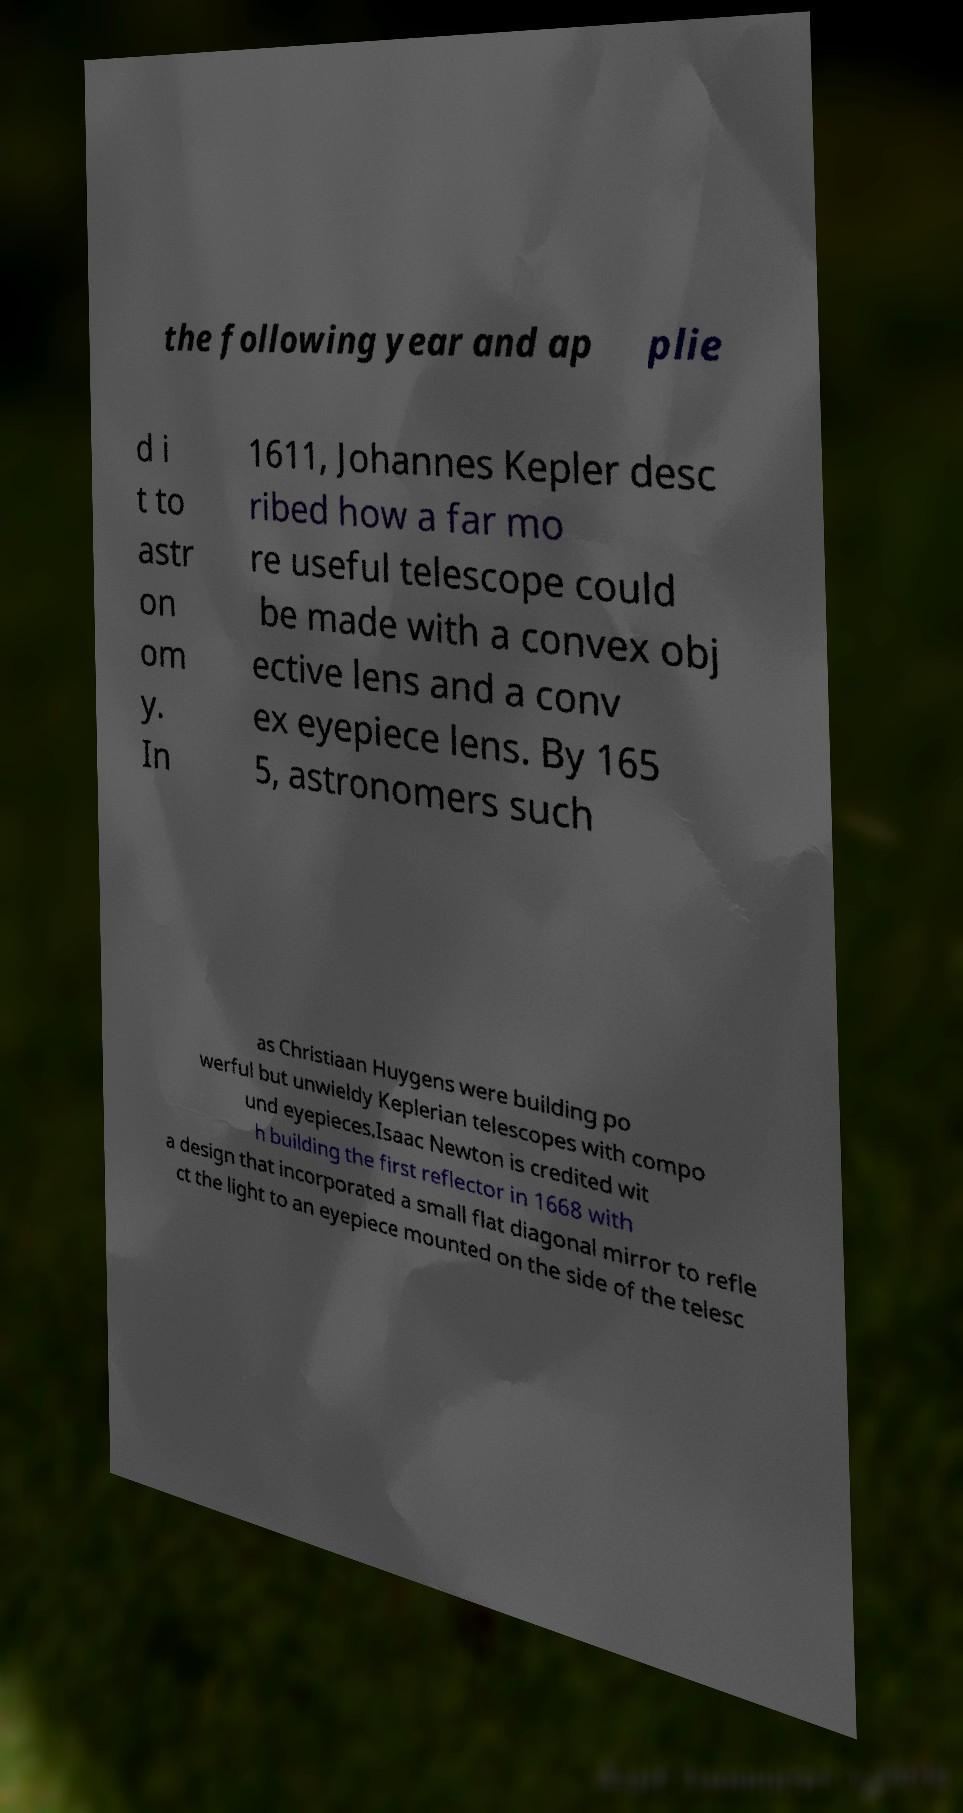I need the written content from this picture converted into text. Can you do that? the following year and ap plie d i t to astr on om y. In 1611, Johannes Kepler desc ribed how a far mo re useful telescope could be made with a convex obj ective lens and a conv ex eyepiece lens. By 165 5, astronomers such as Christiaan Huygens were building po werful but unwieldy Keplerian telescopes with compo und eyepieces.Isaac Newton is credited wit h building the first reflector in 1668 with a design that incorporated a small flat diagonal mirror to refle ct the light to an eyepiece mounted on the side of the telesc 